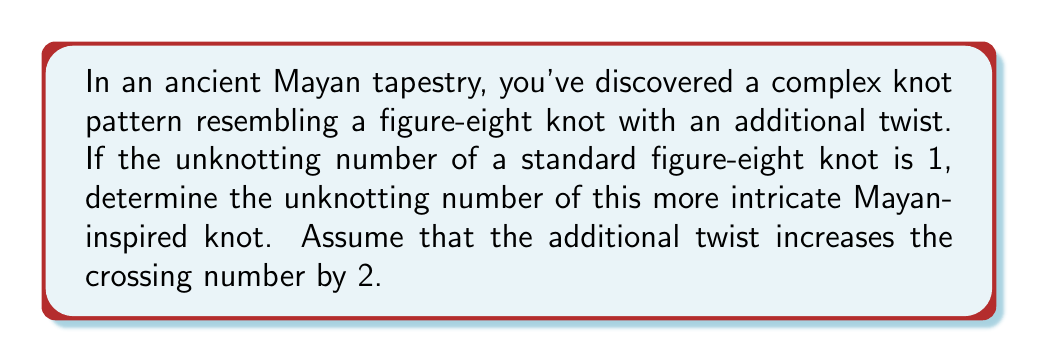Solve this math problem. Let's approach this step-by-step:

1) First, recall that the unknotting number of a knot is the minimum number of times the knot must be passed through itself to untie it.

2) The standard figure-eight knot has an unknotting number of 1. This means it can be transformed into a trivial knot with a single crossing change.

3) The Mayan-inspired knot has an additional twist, which increases the crossing number by 2. This suggests we're dealing with a more complex version of the figure-eight knot.

4) In knot theory, adding twists often increases the unknotting number. However, the relationship isn't always linear.

5) For this particular case, we can consider the additional twist as a separate entity that needs to be undone.

6) To undo this additional twist, we need one more crossing change in addition to the one required for the basic figure-eight knot.

7) Therefore, the unknotting number of this Mayan-inspired knot is:

   $$U = U_{figure-eight} + U_{additional-twist} = 1 + 1 = 2$$

Where $U$ represents the unknotting number.

8) This result aligns with the principle that more complex knots generally have higher unknotting numbers.
Answer: 2 